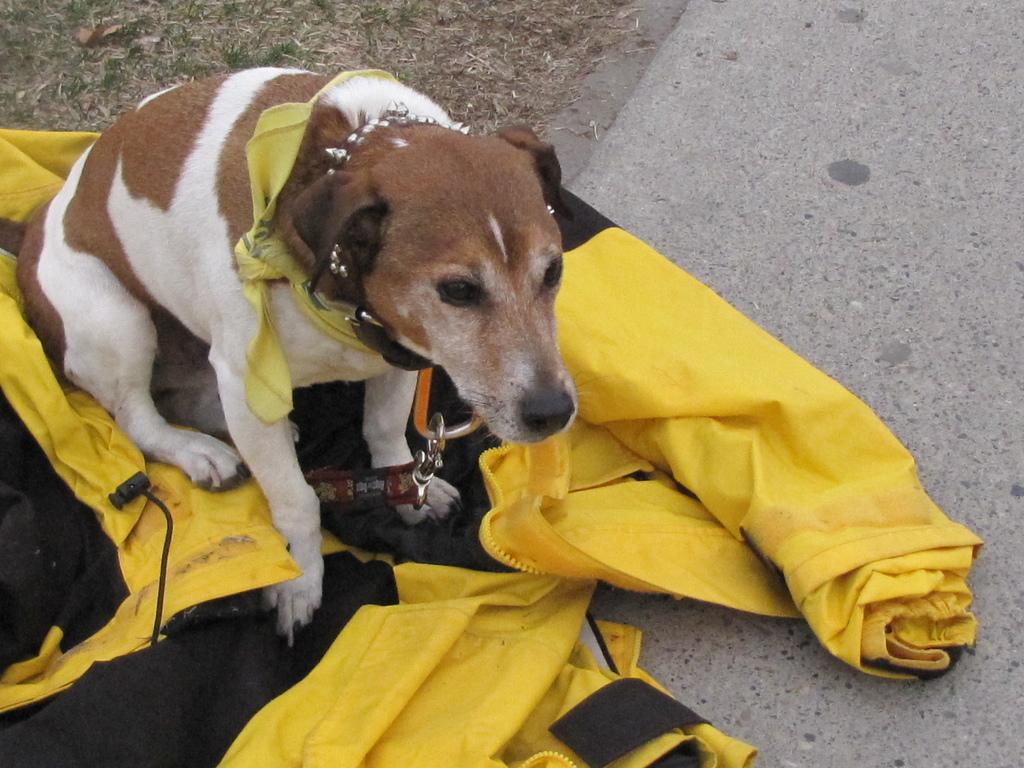What animal is present in the image? There is a dog in the image. Where is the dog located in the image? The dog is on the left side of the image. What is the dog doing or interacting with in the image? The dog is on a jacket. What type of yard can be seen in the background of the image? There is no yard visible in the image; it only features a dog on a jacket. What color crayon is the dog holding in the image? There are no crayons present in the image, and the dog is not holding anything. 